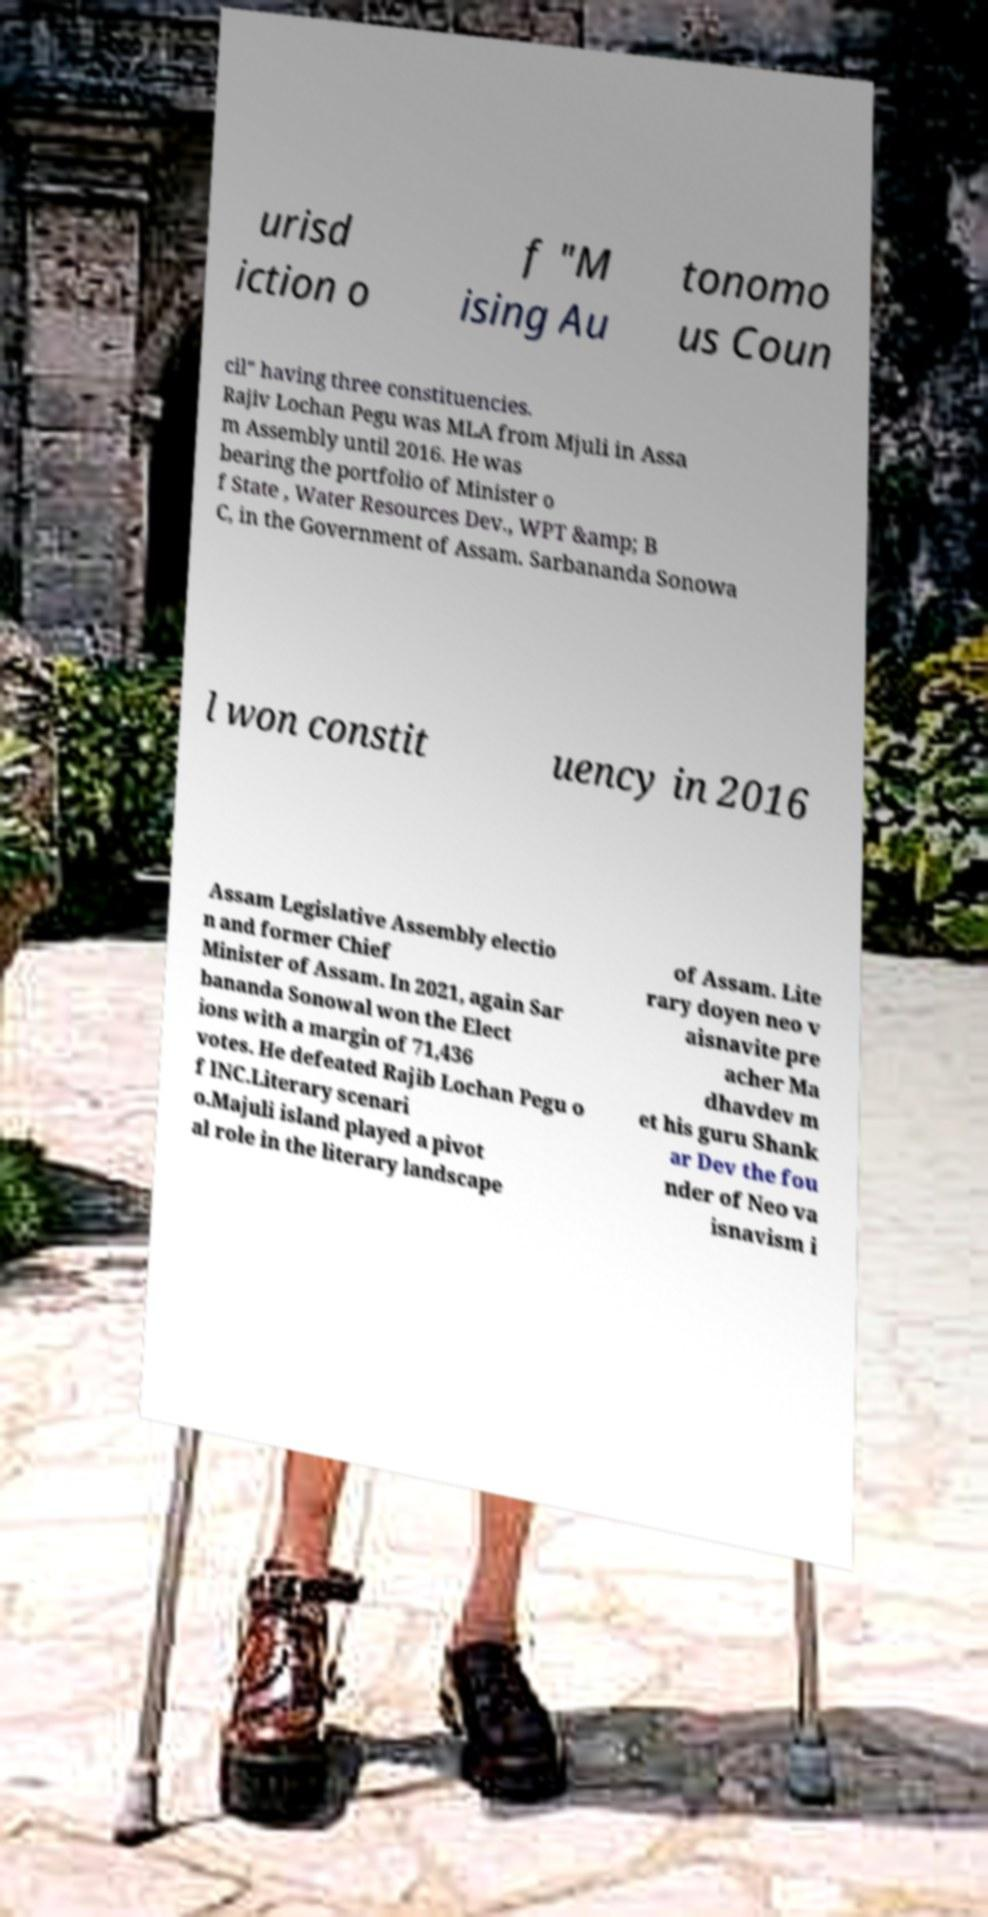I need the written content from this picture converted into text. Can you do that? urisd iction o f "M ising Au tonomo us Coun cil" having three constituencies. Rajiv Lochan Pegu was MLA from Mjuli in Assa m Assembly until 2016. He was bearing the portfolio of Minister o f State , Water Resources Dev., WPT &amp; B C, in the Government of Assam. Sarbananda Sonowa l won constit uency in 2016 Assam Legislative Assembly electio n and former Chief Minister of Assam. In 2021, again Sar bananda Sonowal won the Elect ions with a margin of 71,436 votes. He defeated Rajib Lochan Pegu o f INC.Literary scenari o.Majuli island played a pivot al role in the literary landscape of Assam. Lite rary doyen neo v aisnavite pre acher Ma dhavdev m et his guru Shank ar Dev the fou nder of Neo va isnavism i 